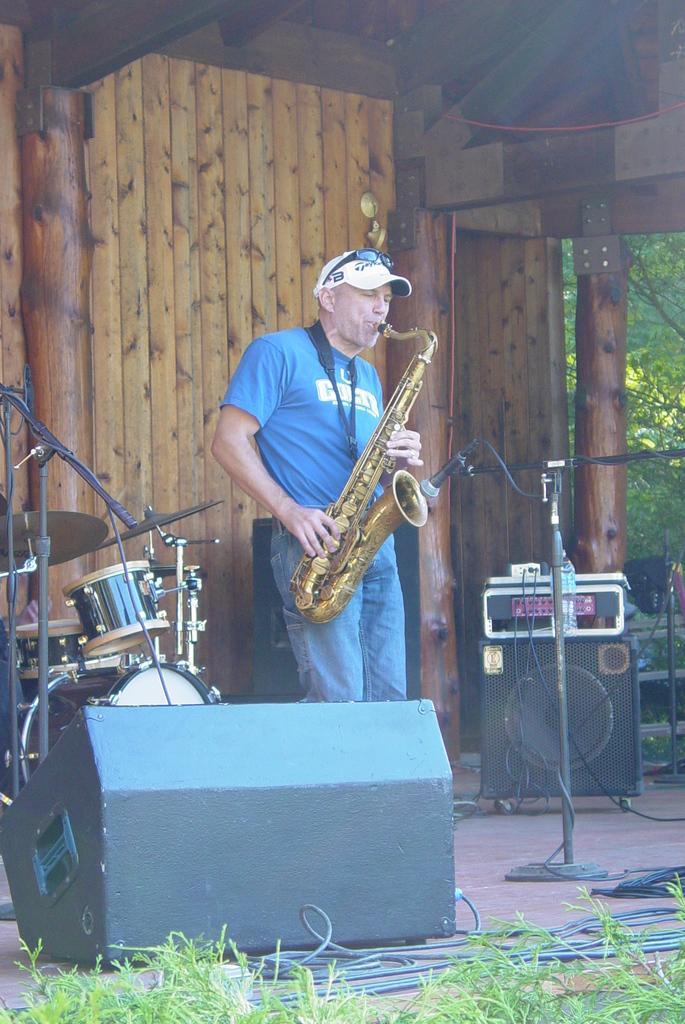In one or two sentences, can you explain what this image depicts? In this image we can see a person holding a musical instrument in his hand. In the right side of the image we can see a microphone on stand. In the left side of the image we can see musical instruments and a stand. In the foreground of the image we can see speakers placed on floor. At the bottom we can see some plants and some cables. At the top of the image we can see wood poles and group of trees. 